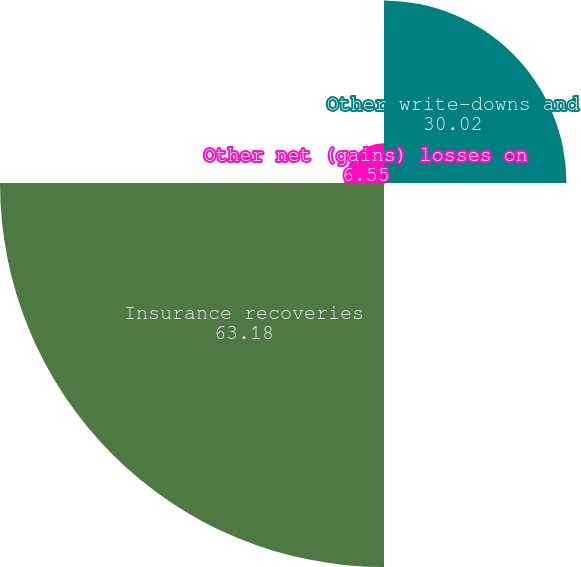Convert chart to OTSL. <chart><loc_0><loc_0><loc_500><loc_500><pie_chart><fcel>Other write-downs and<fcel>Demolition costs<fcel>Insurance recoveries<fcel>Other net (gains) losses on<nl><fcel>30.02%<fcel>0.26%<fcel>63.18%<fcel>6.55%<nl></chart> 